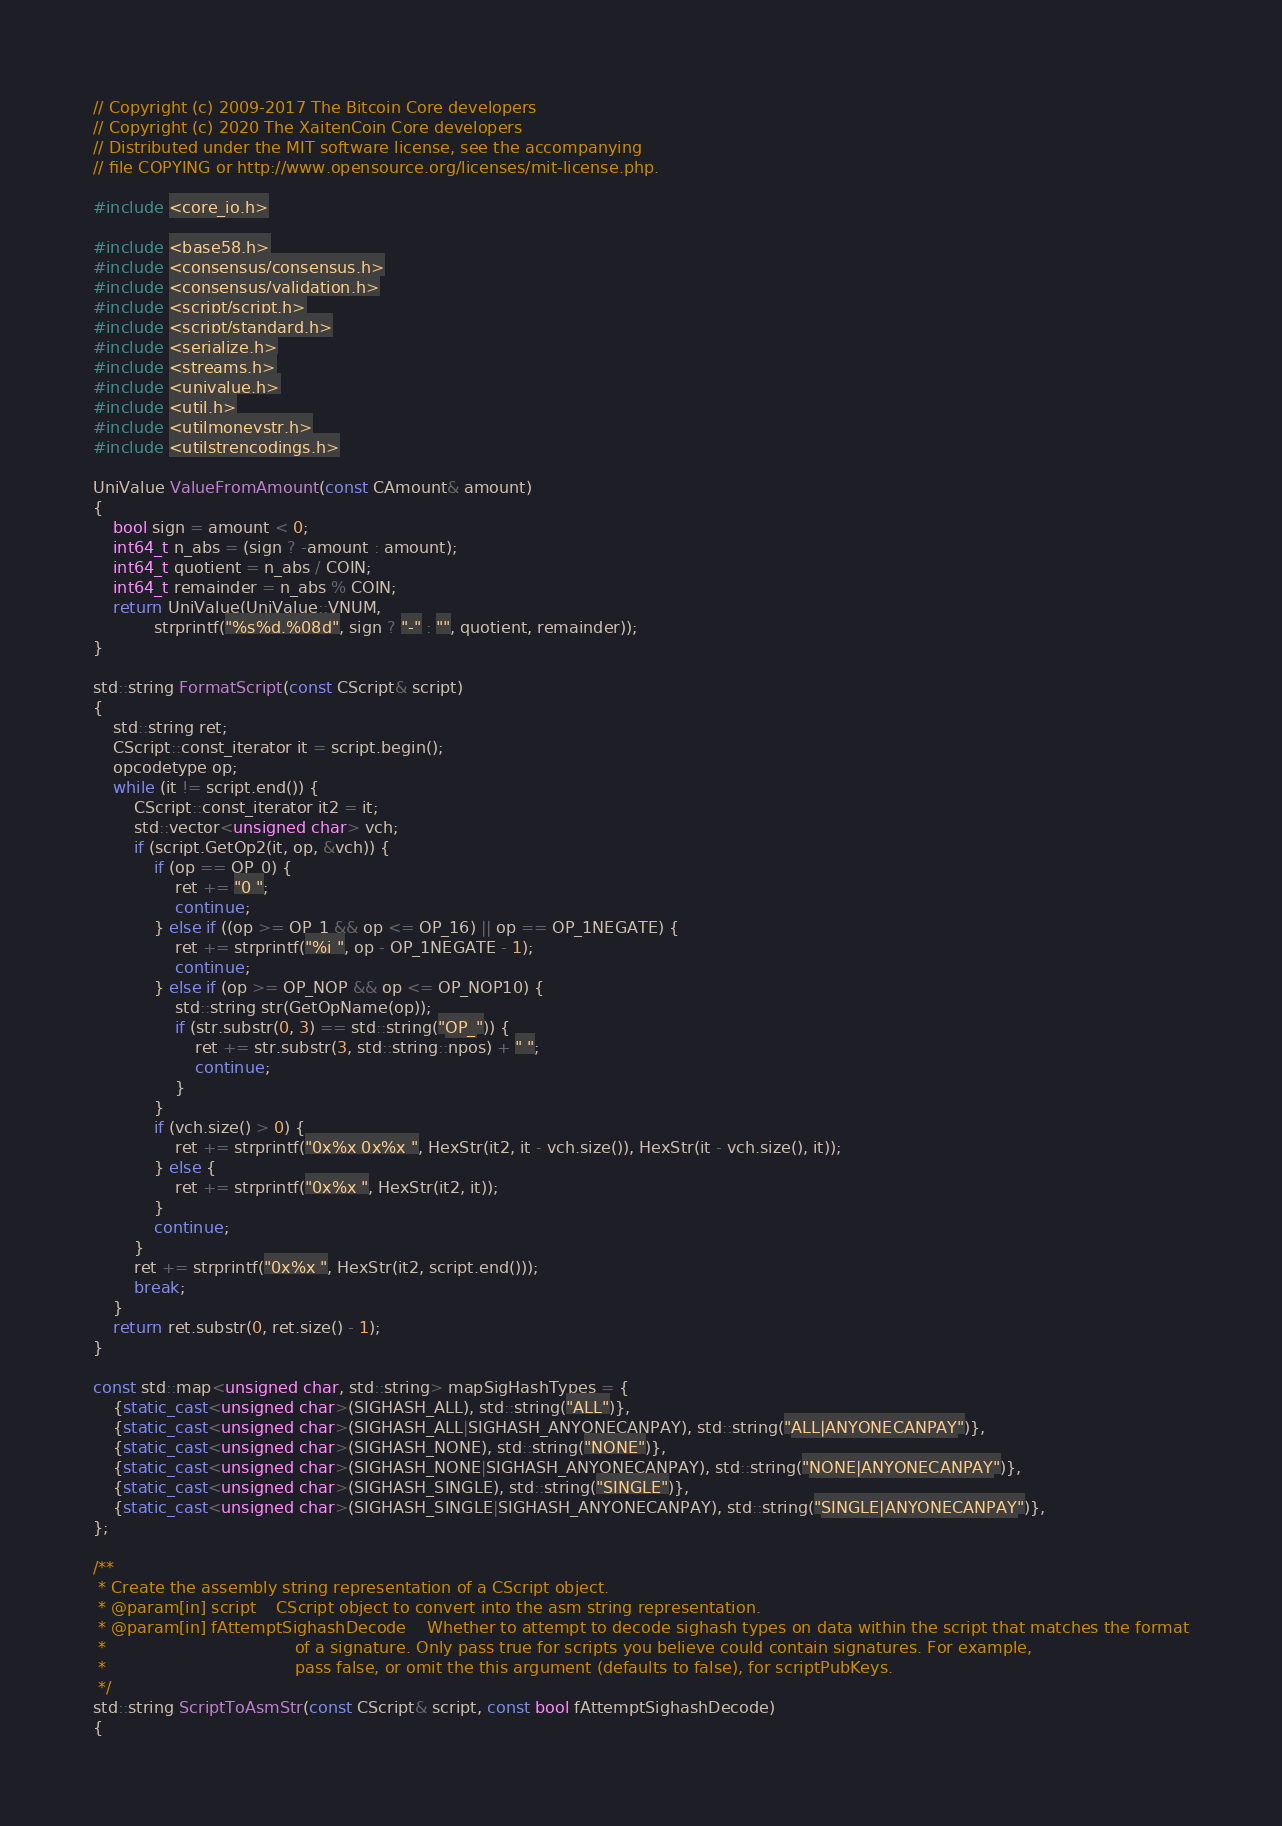<code> <loc_0><loc_0><loc_500><loc_500><_C++_>// Copyright (c) 2009-2017 The Bitcoin Core developers
// Copyright (c) 2020 The XaitenCoin Core developers
// Distributed under the MIT software license, see the accompanying
// file COPYING or http://www.opensource.org/licenses/mit-license.php.

#include <core_io.h>

#include <base58.h>
#include <consensus/consensus.h>
#include <consensus/validation.h>
#include <script/script.h>
#include <script/standard.h>
#include <serialize.h>
#include <streams.h>
#include <univalue.h>
#include <util.h>
#include <utilmoneystr.h>
#include <utilstrencodings.h>

UniValue ValueFromAmount(const CAmount& amount)
{
    bool sign = amount < 0;
    int64_t n_abs = (sign ? -amount : amount);
    int64_t quotient = n_abs / COIN;
    int64_t remainder = n_abs % COIN;
    return UniValue(UniValue::VNUM,
            strprintf("%s%d.%08d", sign ? "-" : "", quotient, remainder));
}

std::string FormatScript(const CScript& script)
{
    std::string ret;
    CScript::const_iterator it = script.begin();
    opcodetype op;
    while (it != script.end()) {
        CScript::const_iterator it2 = it;
        std::vector<unsigned char> vch;
        if (script.GetOp2(it, op, &vch)) {
            if (op == OP_0) {
                ret += "0 ";
                continue;
            } else if ((op >= OP_1 && op <= OP_16) || op == OP_1NEGATE) {
                ret += strprintf("%i ", op - OP_1NEGATE - 1);
                continue;
            } else if (op >= OP_NOP && op <= OP_NOP10) {
                std::string str(GetOpName(op));
                if (str.substr(0, 3) == std::string("OP_")) {
                    ret += str.substr(3, std::string::npos) + " ";
                    continue;
                }
            }
            if (vch.size() > 0) {
                ret += strprintf("0x%x 0x%x ", HexStr(it2, it - vch.size()), HexStr(it - vch.size(), it));
            } else {
                ret += strprintf("0x%x ", HexStr(it2, it));
            }
            continue;
        }
        ret += strprintf("0x%x ", HexStr(it2, script.end()));
        break;
    }
    return ret.substr(0, ret.size() - 1);
}

const std::map<unsigned char, std::string> mapSigHashTypes = {
    {static_cast<unsigned char>(SIGHASH_ALL), std::string("ALL")},
    {static_cast<unsigned char>(SIGHASH_ALL|SIGHASH_ANYONECANPAY), std::string("ALL|ANYONECANPAY")},
    {static_cast<unsigned char>(SIGHASH_NONE), std::string("NONE")},
    {static_cast<unsigned char>(SIGHASH_NONE|SIGHASH_ANYONECANPAY), std::string("NONE|ANYONECANPAY")},
    {static_cast<unsigned char>(SIGHASH_SINGLE), std::string("SINGLE")},
    {static_cast<unsigned char>(SIGHASH_SINGLE|SIGHASH_ANYONECANPAY), std::string("SINGLE|ANYONECANPAY")},
};

/**
 * Create the assembly string representation of a CScript object.
 * @param[in] script    CScript object to convert into the asm string representation.
 * @param[in] fAttemptSighashDecode    Whether to attempt to decode sighash types on data within the script that matches the format
 *                                     of a signature. Only pass true for scripts you believe could contain signatures. For example,
 *                                     pass false, or omit the this argument (defaults to false), for scriptPubKeys.
 */
std::string ScriptToAsmStr(const CScript& script, const bool fAttemptSighashDecode)
{</code> 